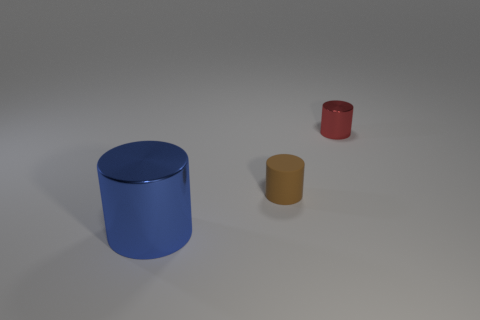Subtract all small brown cylinders. How many cylinders are left? 2 Add 3 big blue shiny objects. How many objects exist? 6 Subtract 3 cylinders. How many cylinders are left? 0 Add 3 big matte cubes. How many big matte cubes exist? 3 Subtract all red cylinders. How many cylinders are left? 2 Subtract 0 yellow cylinders. How many objects are left? 3 Subtract all brown cylinders. Subtract all yellow spheres. How many cylinders are left? 2 Subtract all brown spheres. How many red cylinders are left? 1 Subtract all metallic things. Subtract all tiny red shiny things. How many objects are left? 0 Add 3 brown rubber objects. How many brown rubber objects are left? 4 